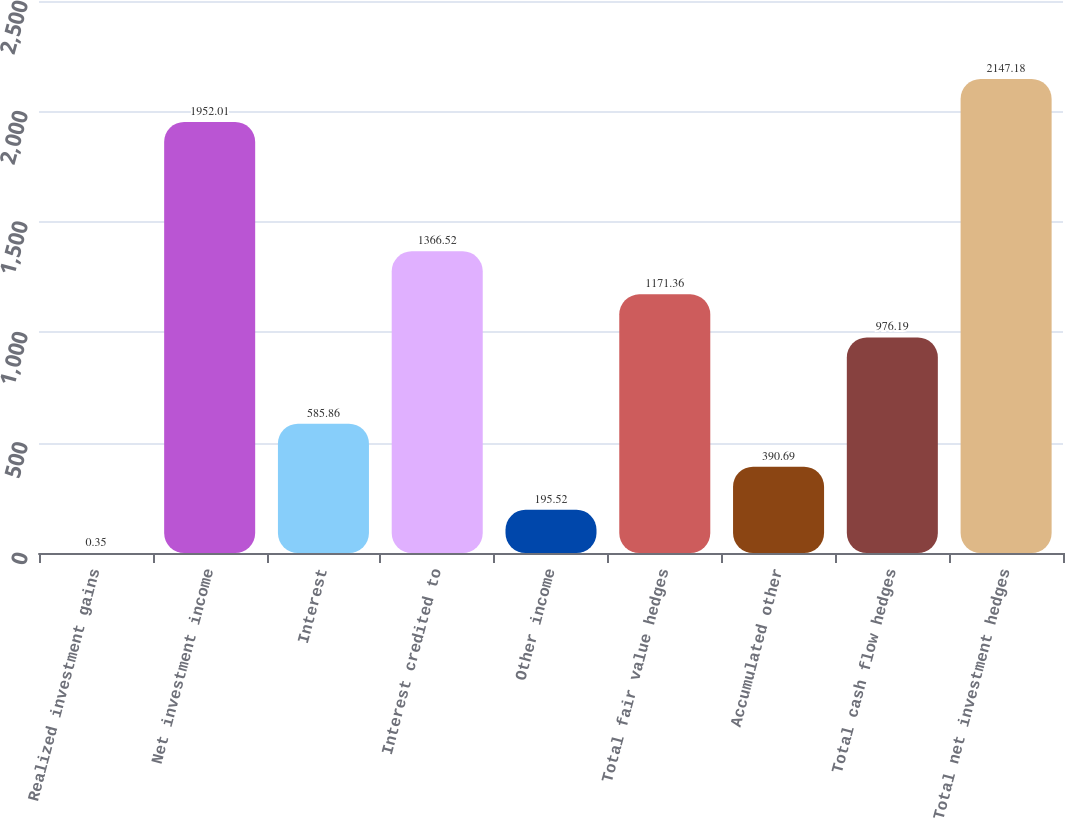Convert chart. <chart><loc_0><loc_0><loc_500><loc_500><bar_chart><fcel>Realized investment gains<fcel>Net investment income<fcel>Interest<fcel>Interest credited to<fcel>Other income<fcel>Total fair value hedges<fcel>Accumulated other<fcel>Total cash flow hedges<fcel>Total net investment hedges<nl><fcel>0.35<fcel>1952.01<fcel>585.86<fcel>1366.52<fcel>195.52<fcel>1171.36<fcel>390.69<fcel>976.19<fcel>2147.18<nl></chart> 